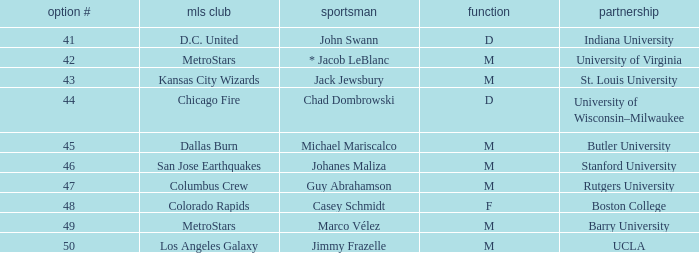Which MLS team has the #41 pick? D.C. United. 